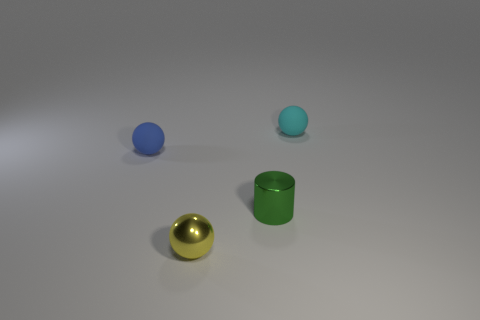Add 2 metal things. How many objects exist? 6 Subtract all cylinders. How many objects are left? 3 Subtract all small blue balls. Subtract all cyan balls. How many objects are left? 2 Add 1 green cylinders. How many green cylinders are left? 2 Add 1 tiny cyan spheres. How many tiny cyan spheres exist? 2 Subtract 0 yellow blocks. How many objects are left? 4 